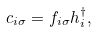<formula> <loc_0><loc_0><loc_500><loc_500>c _ { i \sigma } = f _ { i \sigma } h _ { i } ^ { \dagger } ,</formula> 